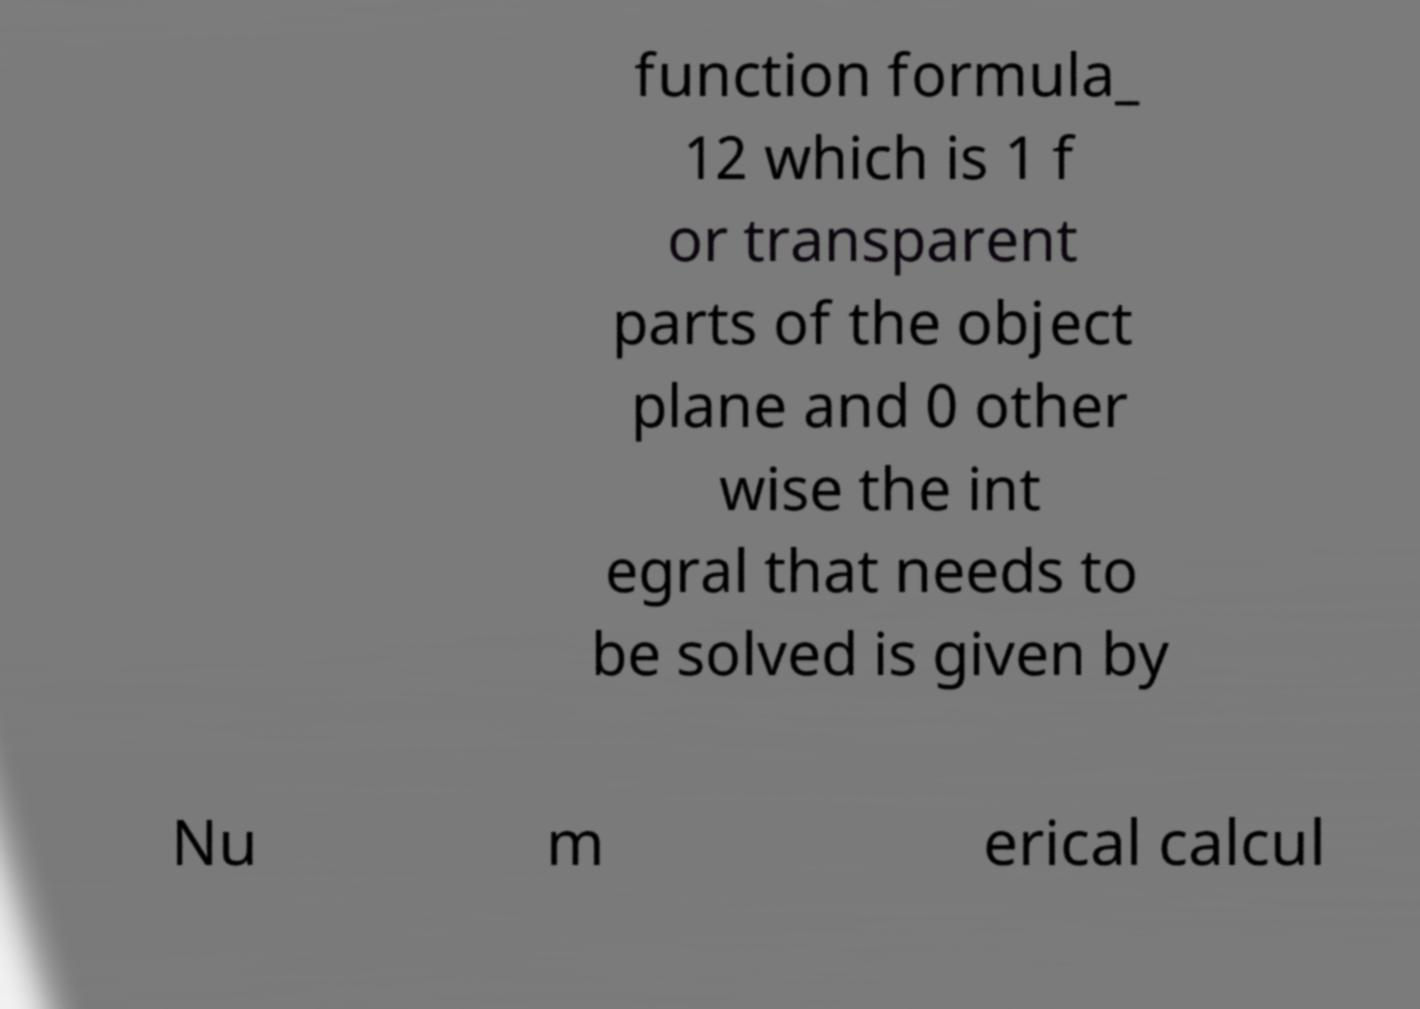Could you extract and type out the text from this image? function formula_ 12 which is 1 f or transparent parts of the object plane and 0 other wise the int egral that needs to be solved is given by Nu m erical calcul 